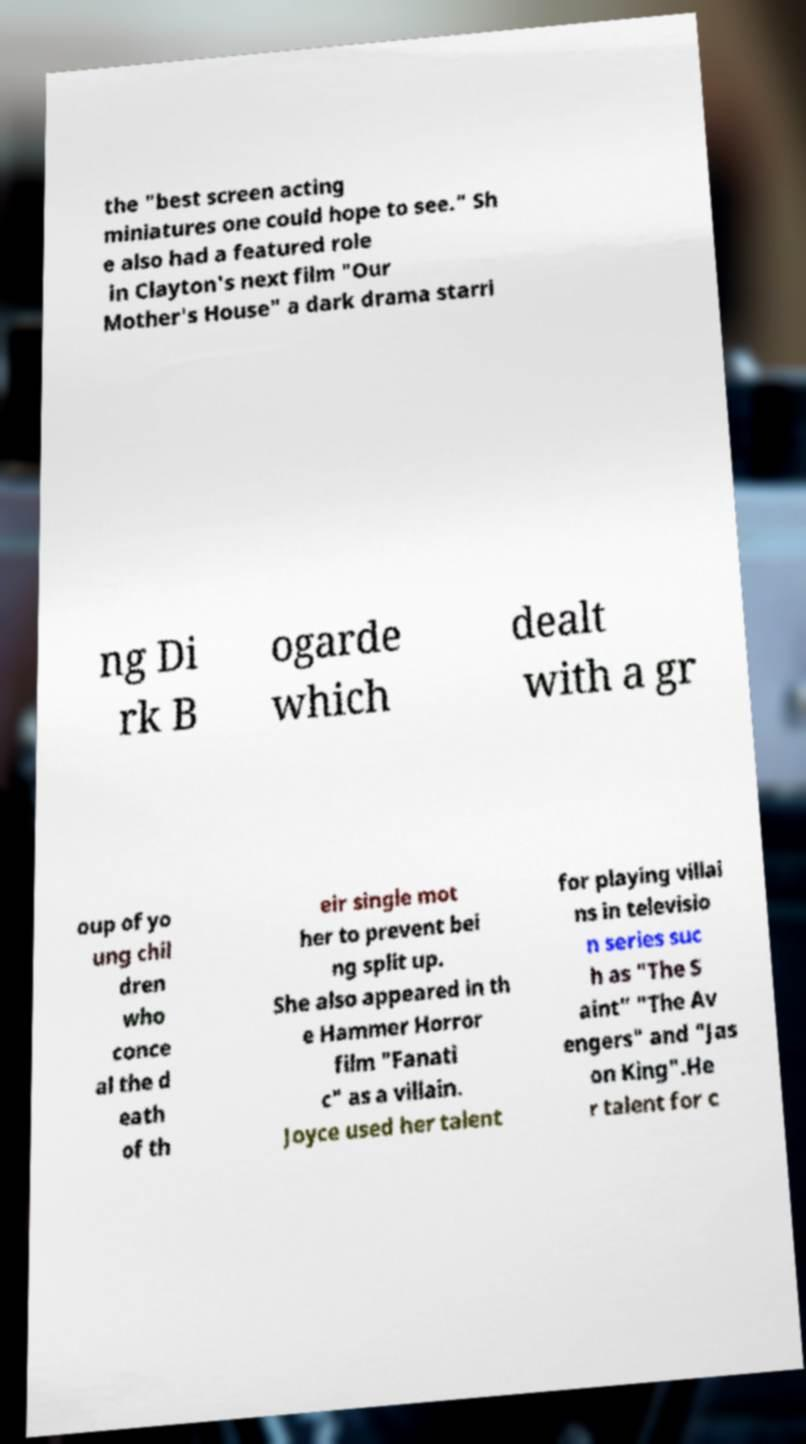Can you read and provide the text displayed in the image?This photo seems to have some interesting text. Can you extract and type it out for me? the "best screen acting miniatures one could hope to see." Sh e also had a featured role in Clayton's next film "Our Mother's House" a dark drama starri ng Di rk B ogarde which dealt with a gr oup of yo ung chil dren who conce al the d eath of th eir single mot her to prevent bei ng split up. She also appeared in th e Hammer Horror film "Fanati c" as a villain. Joyce used her talent for playing villai ns in televisio n series suc h as "The S aint" "The Av engers" and "Jas on King".He r talent for c 